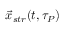Convert formula to latex. <formula><loc_0><loc_0><loc_500><loc_500>{ \vec { x } } _ { s t r } ( t , \tau _ { P } )</formula> 